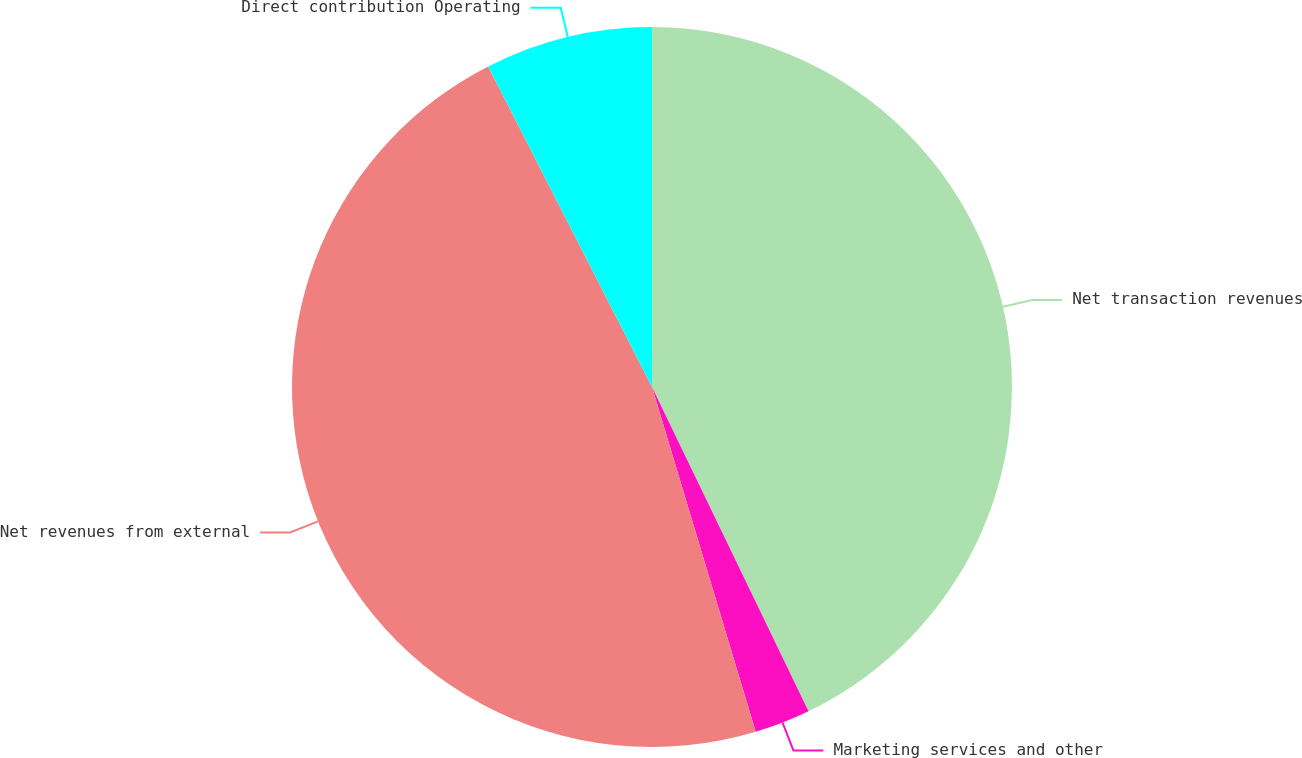<chart> <loc_0><loc_0><loc_500><loc_500><pie_chart><fcel>Net transaction revenues<fcel>Marketing services and other<fcel>Net revenues from external<fcel>Direct contribution Operating<nl><fcel>42.84%<fcel>2.51%<fcel>47.13%<fcel>7.52%<nl></chart> 